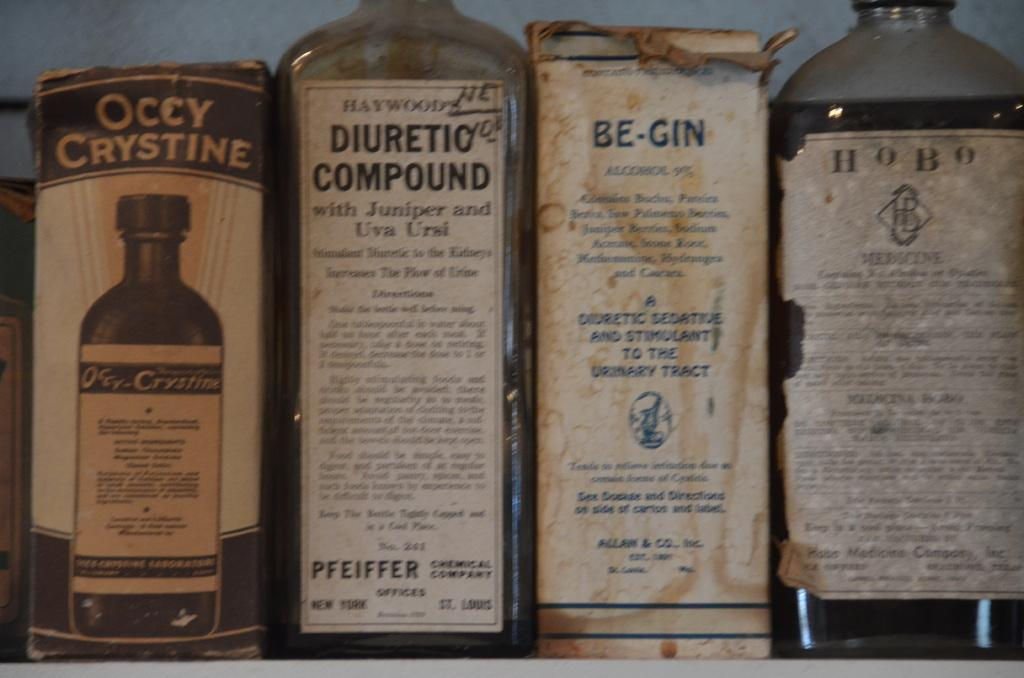<image>
Share a concise interpretation of the image provided. Bottle of HOBO next to a box of Be-Gin on a shelf. 